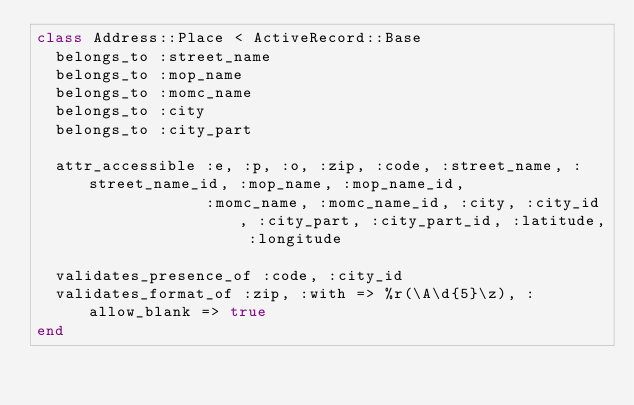<code> <loc_0><loc_0><loc_500><loc_500><_Ruby_>class Address::Place < ActiveRecord::Base
  belongs_to :street_name
  belongs_to :mop_name
  belongs_to :momc_name
  belongs_to :city
  belongs_to :city_part

  attr_accessible :e, :p, :o, :zip, :code, :street_name, :street_name_id, :mop_name, :mop_name_id,
                  :momc_name, :momc_name_id, :city, :city_id, :city_part, :city_part_id, :latitude, :longitude

  validates_presence_of :code, :city_id
  validates_format_of :zip, :with => %r(\A\d{5}\z), :allow_blank => true
end
</code> 